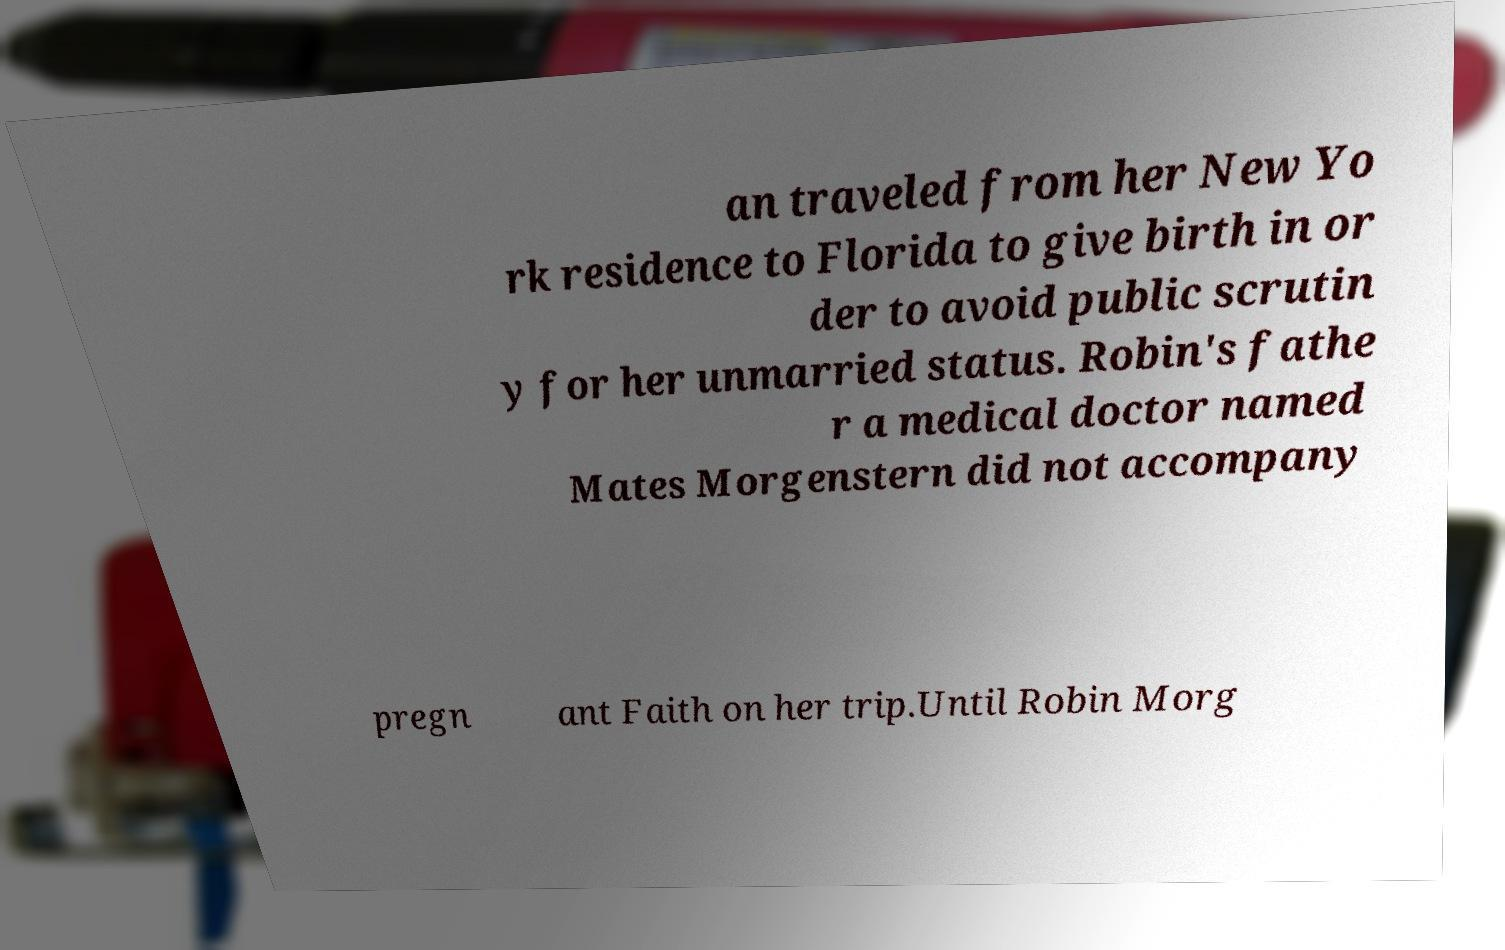Please identify and transcribe the text found in this image. an traveled from her New Yo rk residence to Florida to give birth in or der to avoid public scrutin y for her unmarried status. Robin's fathe r a medical doctor named Mates Morgenstern did not accompany pregn ant Faith on her trip.Until Robin Morg 